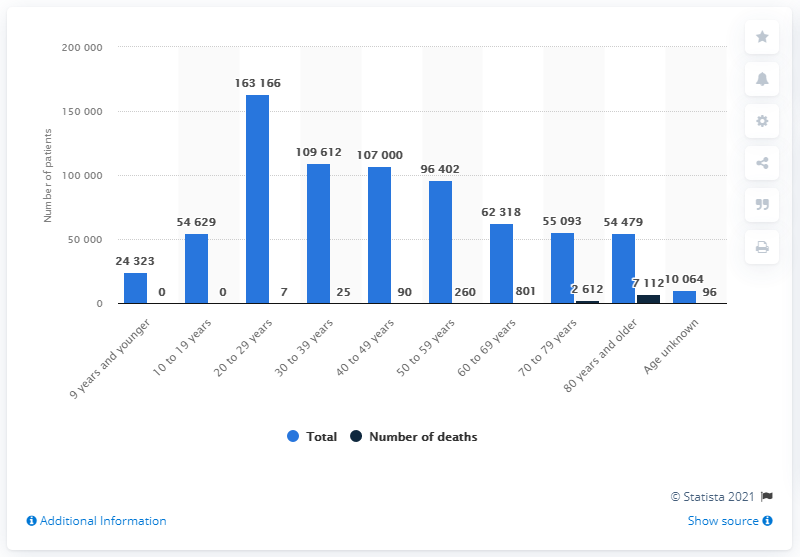Give some essential details in this illustration. As of February 21, 2023, a total of 7,112 people have died from COVID-19 in Japan. As of June 2, 2021, there were 163,166 cases of COVID-19 in Japan. According to the data, the age group with the highest number of deaths was 80 years and older. 